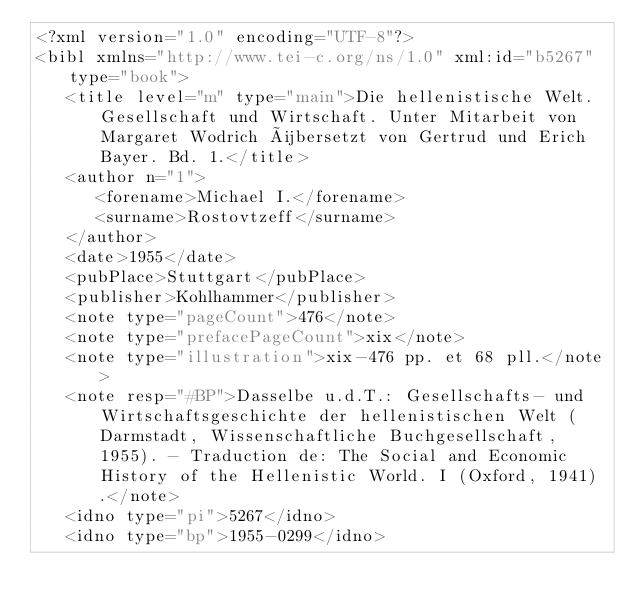Convert code to text. <code><loc_0><loc_0><loc_500><loc_500><_XML_><?xml version="1.0" encoding="UTF-8"?>
<bibl xmlns="http://www.tei-c.org/ns/1.0" xml:id="b5267" type="book">
   <title level="m" type="main">Die hellenistische Welt. Gesellschaft und Wirtschaft. Unter Mitarbeit von Margaret Wodrich übersetzt von Gertrud und Erich Bayer. Bd. 1.</title>
   <author n="1">
      <forename>Michael I.</forename>
      <surname>Rostovtzeff</surname>
   </author>
   <date>1955</date>
   <pubPlace>Stuttgart</pubPlace>
   <publisher>Kohlhammer</publisher>
   <note type="pageCount">476</note>
   <note type="prefacePageCount">xix</note>
   <note type="illustration">xix-476 pp. et 68 pll.</note>
   <note resp="#BP">Dasselbe u.d.T.: Gesellschafts- und Wirtschaftsgeschichte der hellenistischen Welt (Darmstadt, Wissenschaftliche Buchgesellschaft, 1955). - Traduction de: The Social and Economic History of the Hellenistic World. I (Oxford, 1941).</note>
   <idno type="pi">5267</idno>
   <idno type="bp">1955-0299</idno></code> 